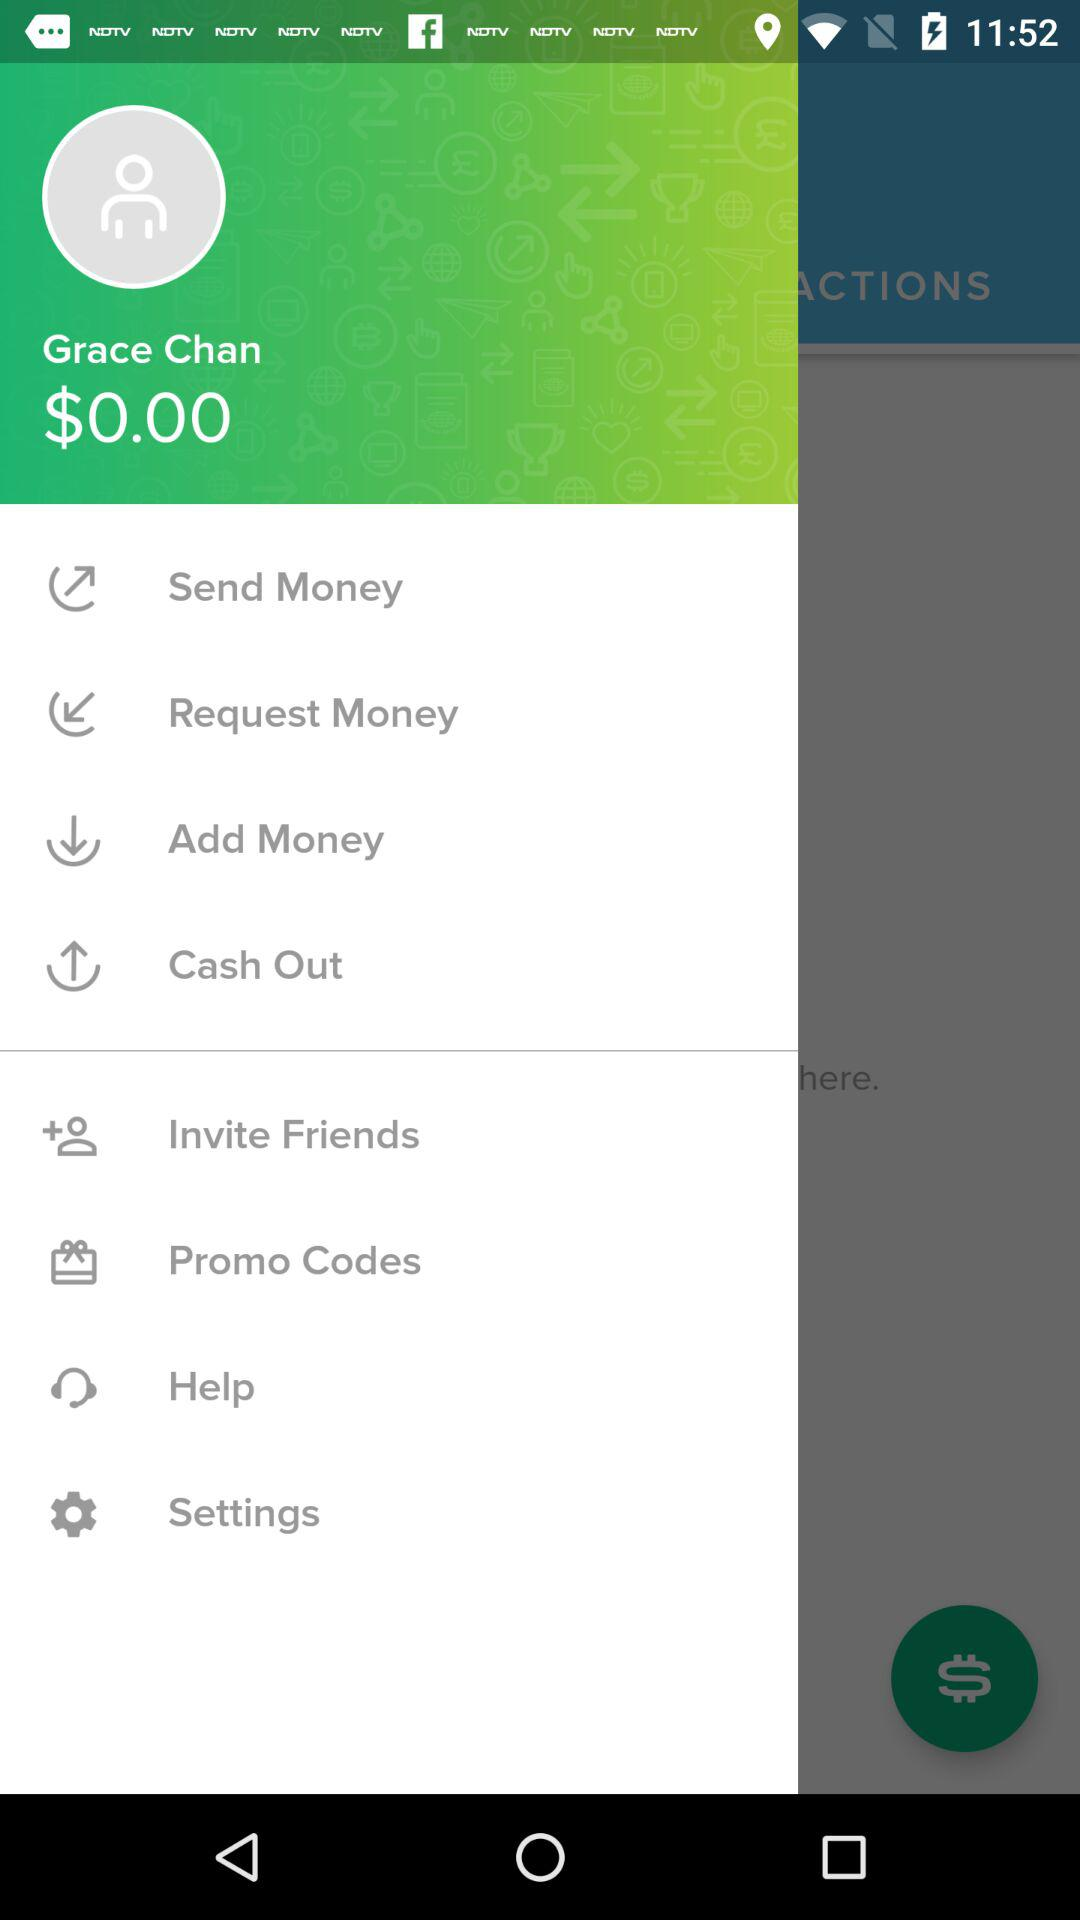What is the user name? The user name is Grace Chan. 